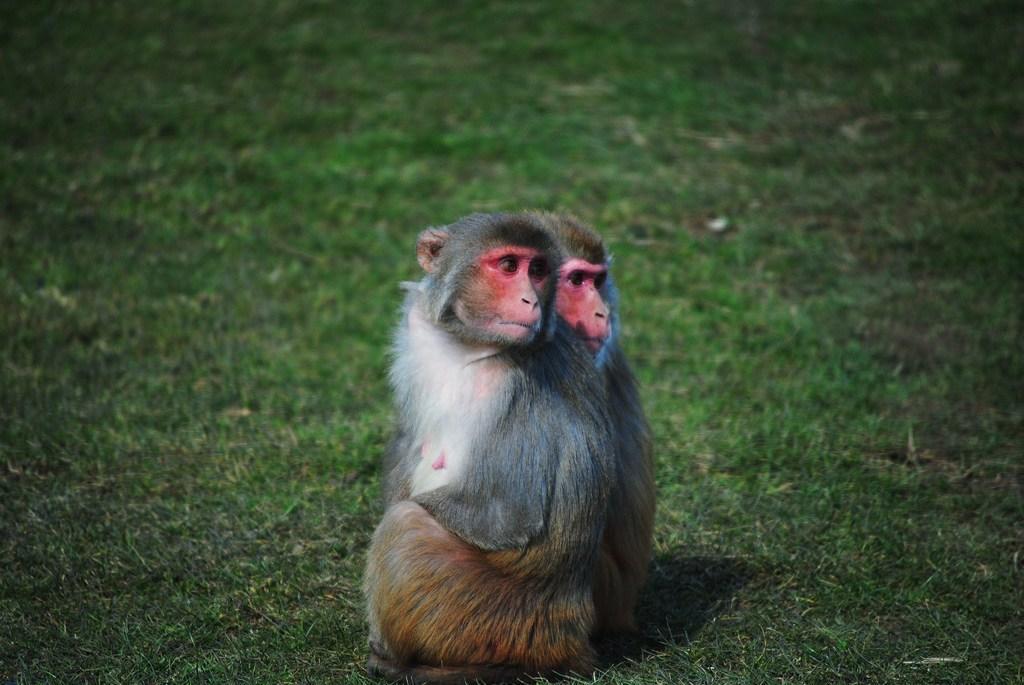Describe this image in one or two sentences. In the center of the image we can see a two faced monkey on the grass. 